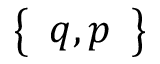Convert formula to latex. <formula><loc_0><loc_0><loc_500><loc_500>\left \{ \begin{array} { l } { q , p } \end{array} \right \}</formula> 